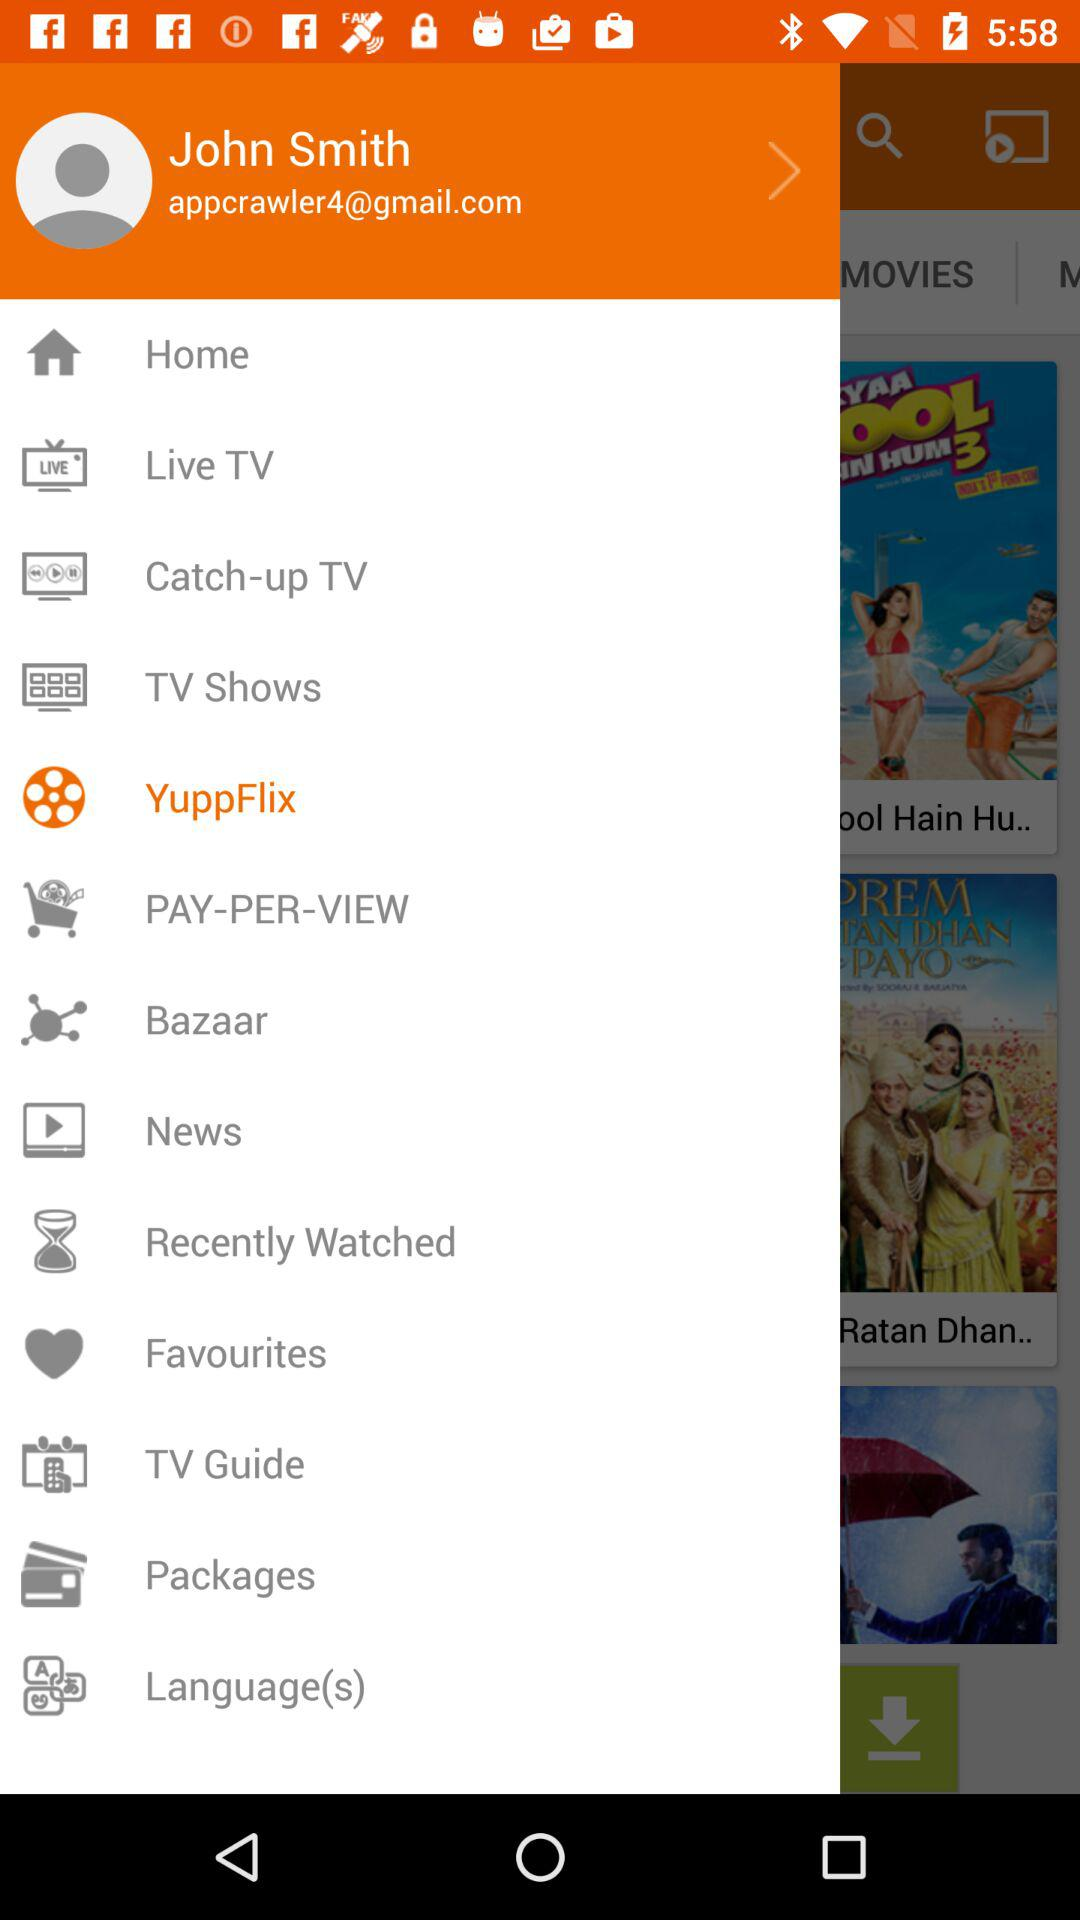What is the user name? The user name is John Smith. 